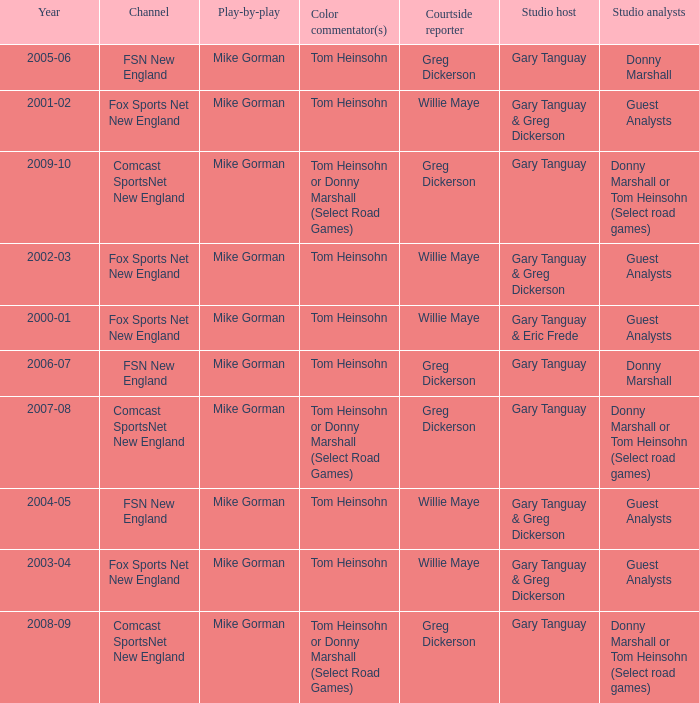WHich Color commentatorhas a Studio host of gary tanguay & eric frede? Tom Heinsohn. 